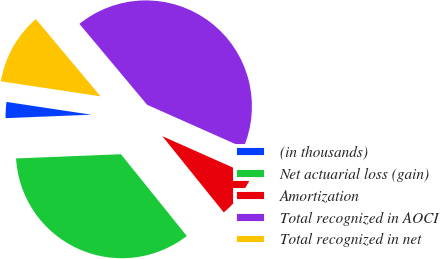<chart> <loc_0><loc_0><loc_500><loc_500><pie_chart><fcel>(in thousands)<fcel>Net actuarial loss (gain)<fcel>Amortization<fcel>Total recognized in AOCI<fcel>Total recognized in net<nl><fcel>3.03%<fcel>35.15%<fcel>7.55%<fcel>42.75%<fcel>11.52%<nl></chart> 